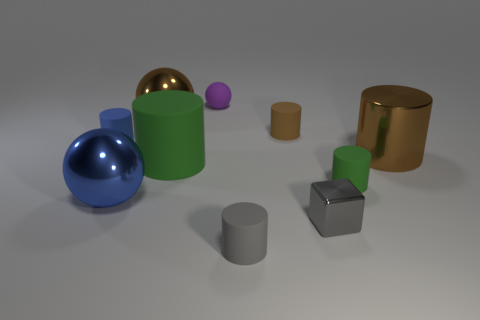Subtract 3 cylinders. How many cylinders are left? 3 Subtract all green cylinders. How many cylinders are left? 4 Subtract all brown shiny cylinders. How many cylinders are left? 5 Subtract all cyan cylinders. Subtract all red balls. How many cylinders are left? 6 Subtract all blocks. How many objects are left? 9 Add 1 metallic balls. How many metallic balls are left? 3 Add 8 yellow shiny cylinders. How many yellow shiny cylinders exist? 8 Subtract 0 cyan balls. How many objects are left? 10 Subtract all big matte things. Subtract all small matte balls. How many objects are left? 8 